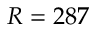Convert formula to latex. <formula><loc_0><loc_0><loc_500><loc_500>R = 2 8 7</formula> 